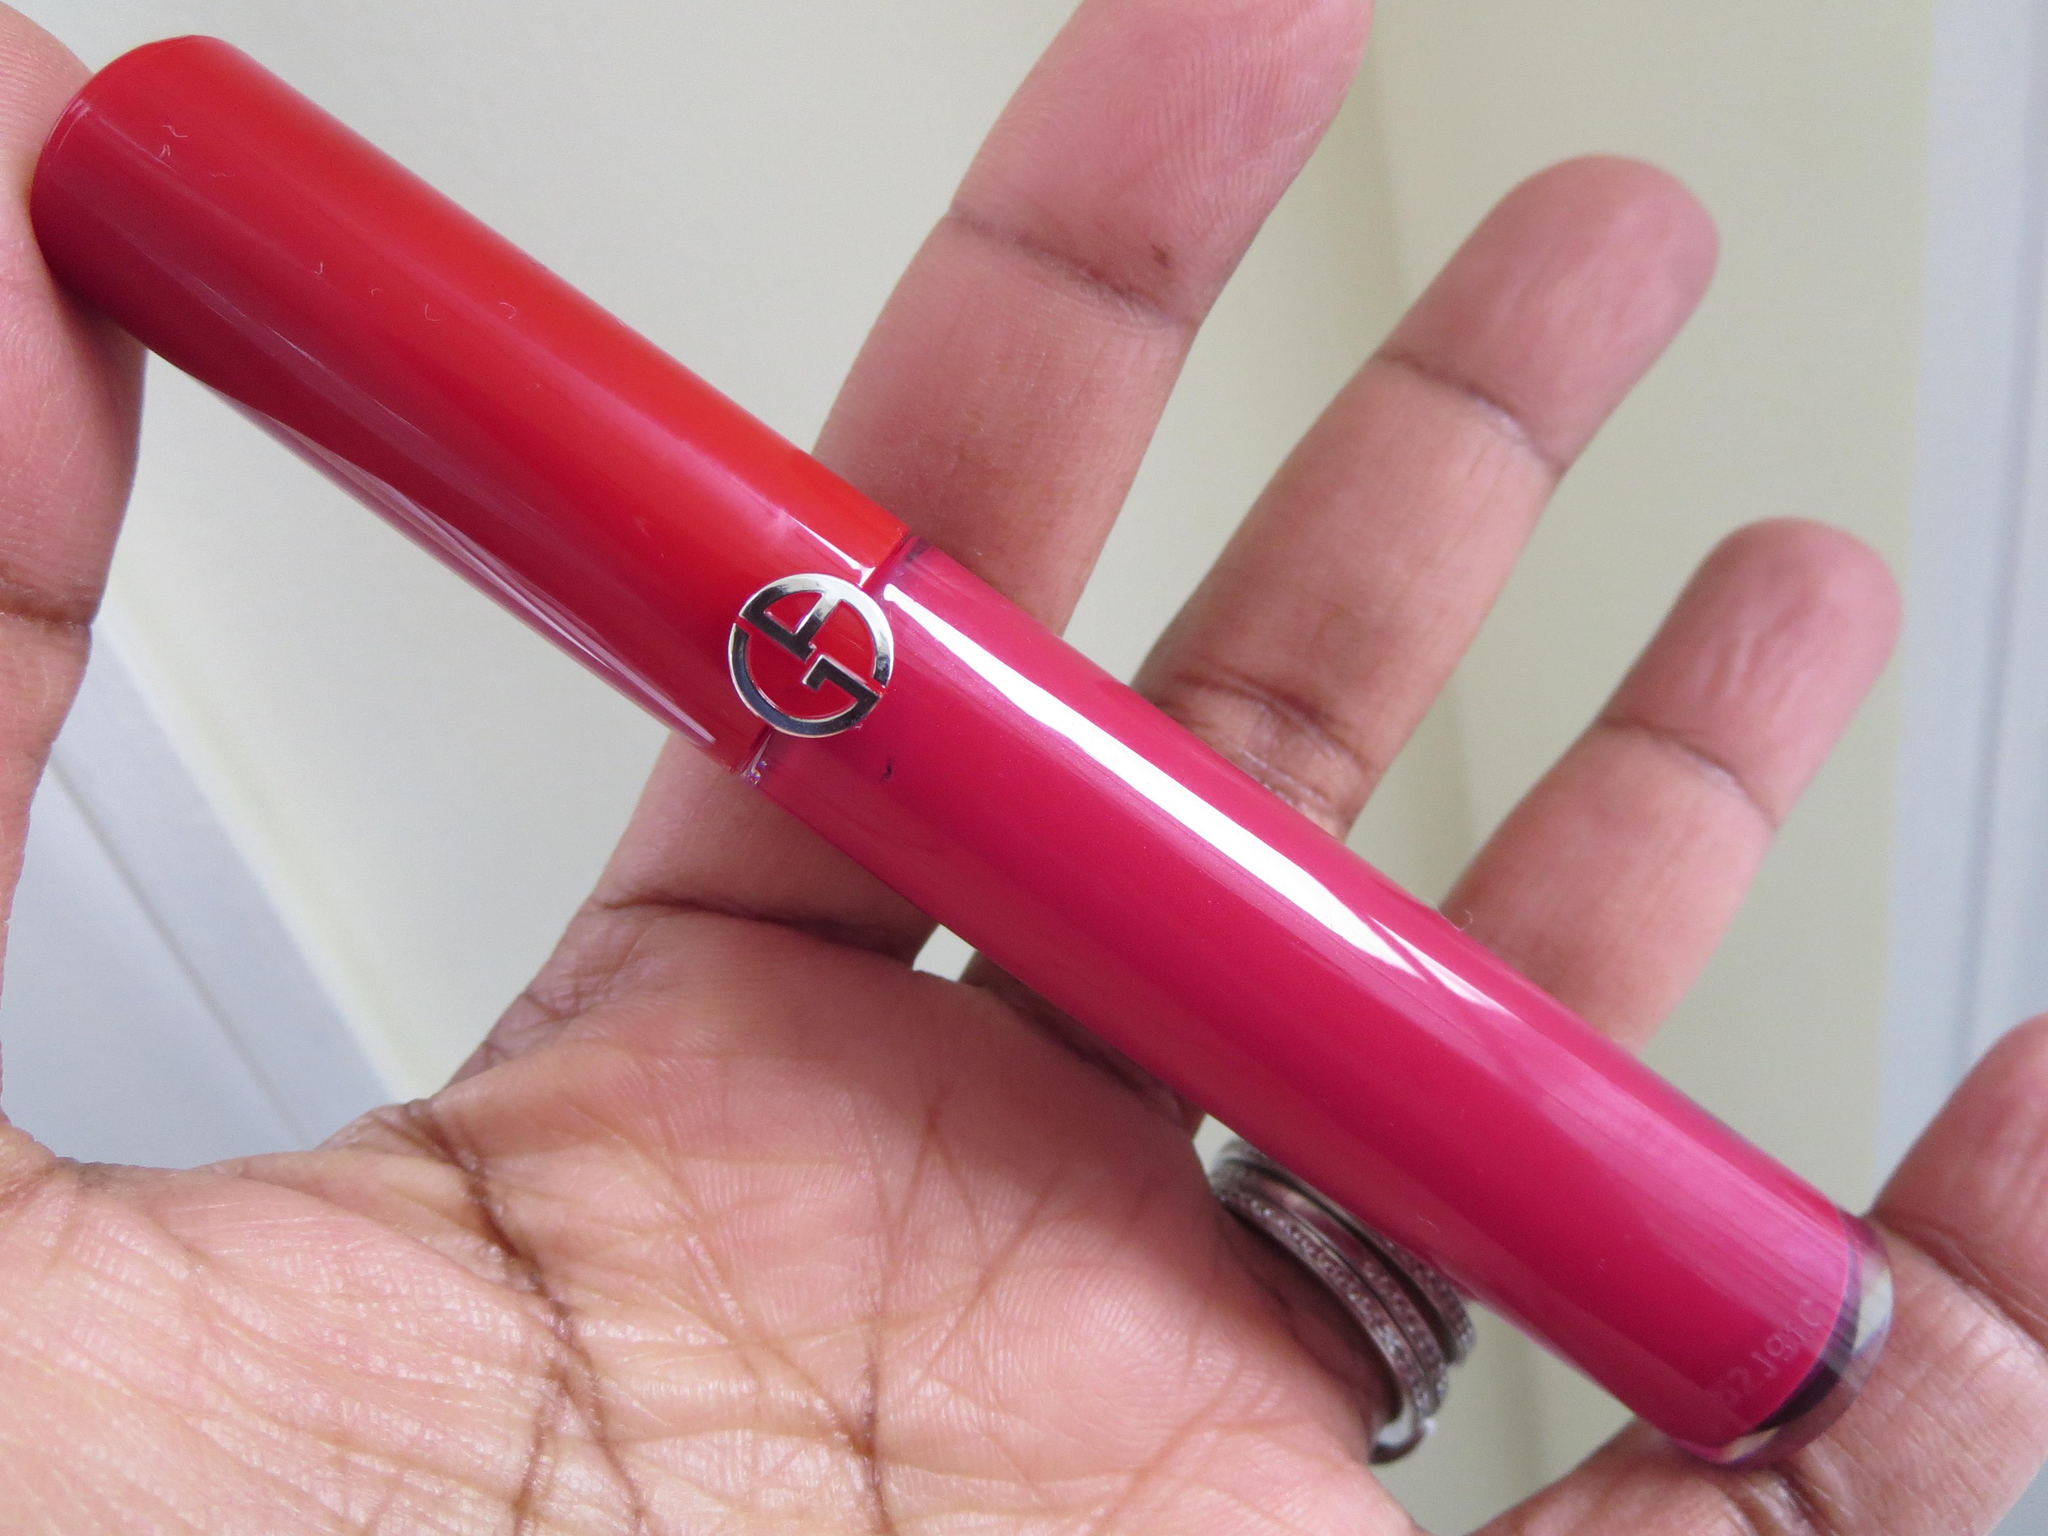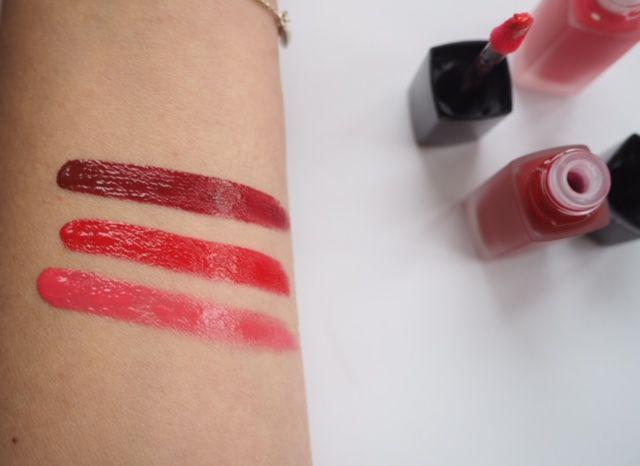The first image is the image on the left, the second image is the image on the right. Given the left and right images, does the statement "Each image shows skin with three lipstick sample stripes on it." hold true? Answer yes or no. No. The first image is the image on the left, the second image is the image on the right. Analyze the images presented: Is the assertion "One of the images does not have three stripes drawn onto skin." valid? Answer yes or no. Yes. 